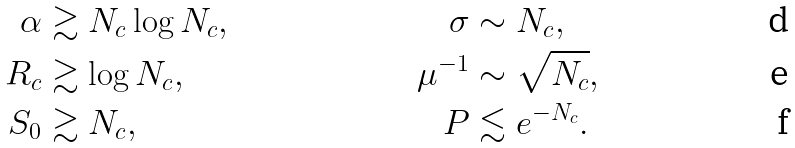Convert formula to latex. <formula><loc_0><loc_0><loc_500><loc_500>\alpha & \gtrsim N _ { c } \log N _ { c } , & \sigma & \sim N _ { c } , \\ R _ { c } & \gtrsim \log N _ { c } , & \mu ^ { - 1 } & \sim \sqrt { N _ { c } } , \\ S _ { 0 } & \gtrsim N _ { c } , & P & \lesssim e ^ { - N _ { c } } .</formula> 